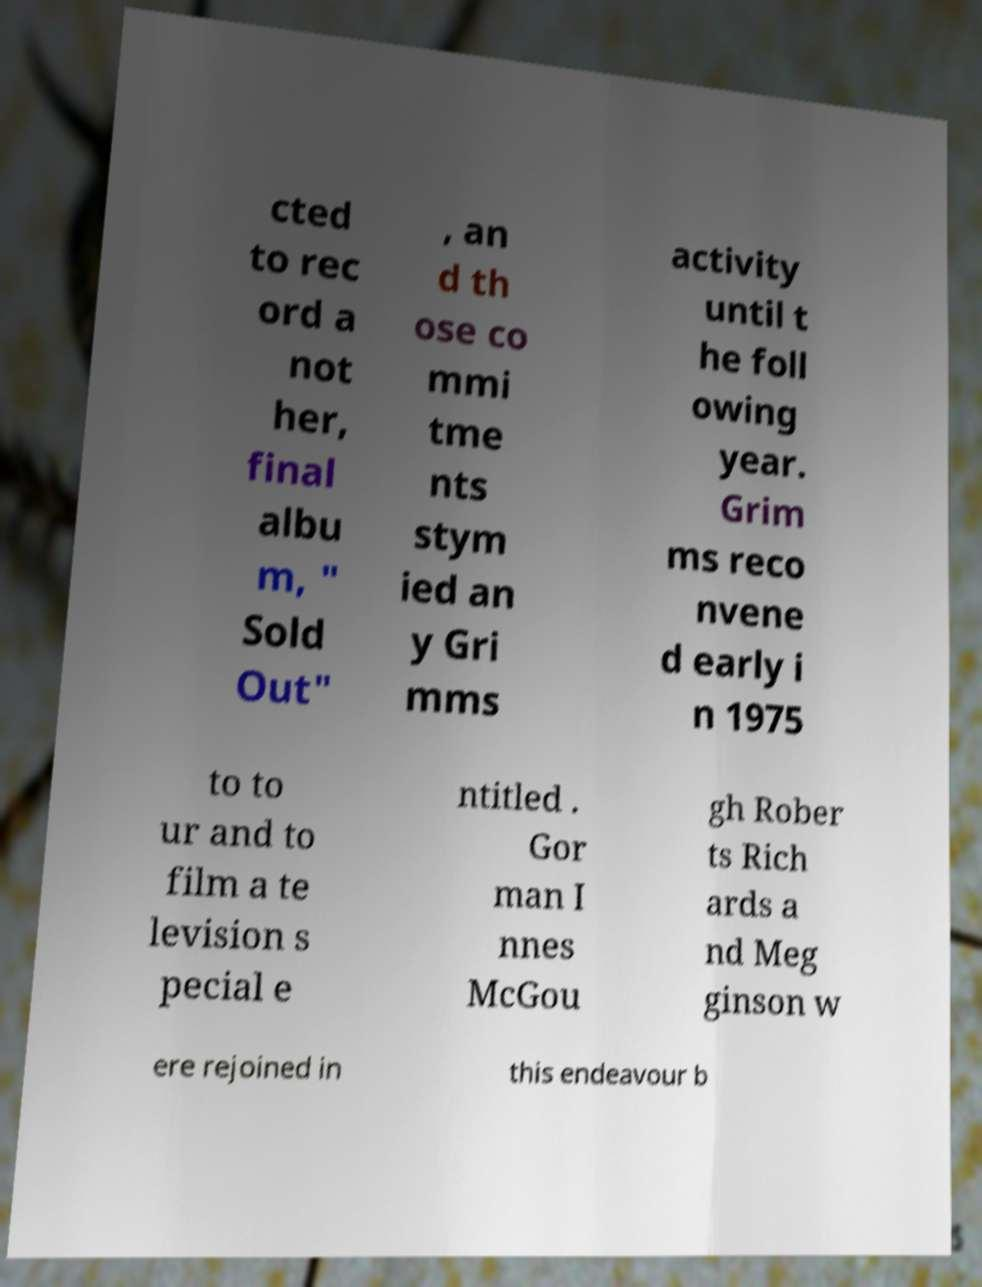Can you read and provide the text displayed in the image?This photo seems to have some interesting text. Can you extract and type it out for me? cted to rec ord a not her, final albu m, " Sold Out" , an d th ose co mmi tme nts stym ied an y Gri mms activity until t he foll owing year. Grim ms reco nvene d early i n 1975 to to ur and to film a te levision s pecial e ntitled . Gor man I nnes McGou gh Rober ts Rich ards a nd Meg ginson w ere rejoined in this endeavour b 